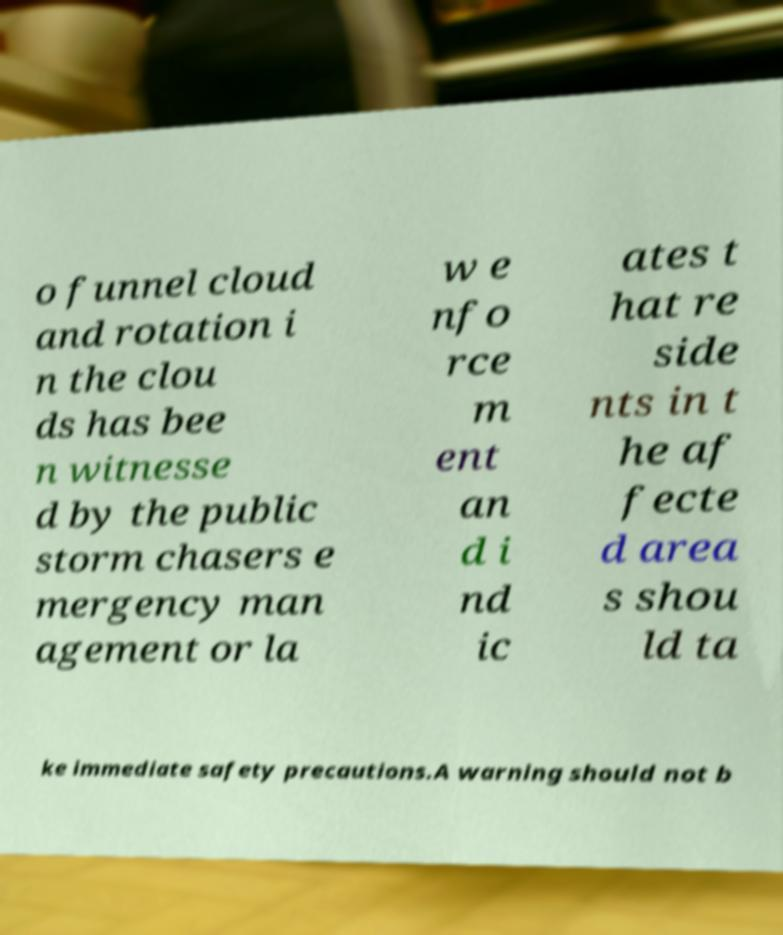Can you read and provide the text displayed in the image?This photo seems to have some interesting text. Can you extract and type it out for me? o funnel cloud and rotation i n the clou ds has bee n witnesse d by the public storm chasers e mergency man agement or la w e nfo rce m ent an d i nd ic ates t hat re side nts in t he af fecte d area s shou ld ta ke immediate safety precautions.A warning should not b 